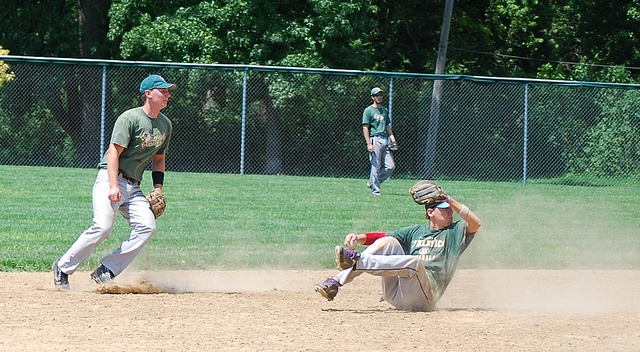Describe the objects in this image and their specific colors. I can see people in black, darkgray, lightgray, and gray tones, people in black, white, darkgray, and gray tones, people in black, gray, blue, and teal tones, baseball glove in black, darkgray, lightgray, and gray tones, and baseball glove in black, gray, tan, and darkgray tones in this image. 